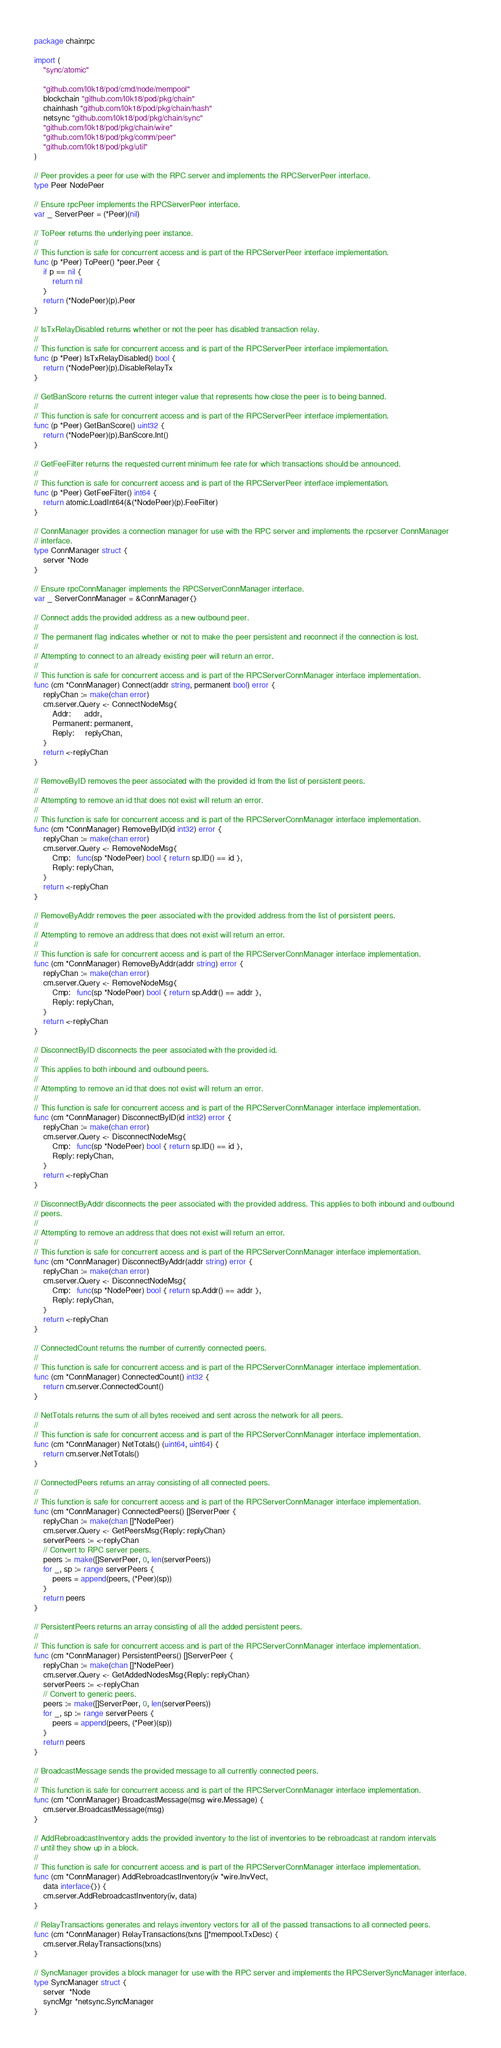<code> <loc_0><loc_0><loc_500><loc_500><_Go_>package chainrpc

import (
	"sync/atomic"

	"github.com/l0k18/pod/cmd/node/mempool"
	blockchain "github.com/l0k18/pod/pkg/chain"
	chainhash "github.com/l0k18/pod/pkg/chain/hash"
	netsync "github.com/l0k18/pod/pkg/chain/sync"
	"github.com/l0k18/pod/pkg/chain/wire"
	"github.com/l0k18/pod/pkg/comm/peer"
	"github.com/l0k18/pod/pkg/util"
)

// Peer provides a peer for use with the RPC server and implements the RPCServerPeer interface.
type Peer NodePeer

// Ensure rpcPeer implements the RPCServerPeer interface.
var _ ServerPeer = (*Peer)(nil)

// ToPeer returns the underlying peer instance.
//
// This function is safe for concurrent access and is part of the RPCServerPeer interface implementation.
func (p *Peer) ToPeer() *peer.Peer {
	if p == nil {
		return nil
	}
	return (*NodePeer)(p).Peer
}

// IsTxRelayDisabled returns whether or not the peer has disabled transaction relay.
//
// This function is safe for concurrent access and is part of the RPCServerPeer interface implementation.
func (p *Peer) IsTxRelayDisabled() bool {
	return (*NodePeer)(p).DisableRelayTx
}

// GetBanScore returns the current integer value that represents how close the peer is to being banned.
//
// This function is safe for concurrent access and is part of the RPCServerPeer interface implementation.
func (p *Peer) GetBanScore() uint32 {
	return (*NodePeer)(p).BanScore.Int()
}

// GetFeeFilter returns the requested current minimum fee rate for which transactions should be announced.
//
// This function is safe for concurrent access and is part of the RPCServerPeer interface implementation.
func (p *Peer) GetFeeFilter() int64 {
	return atomic.LoadInt64(&(*NodePeer)(p).FeeFilter)
}

// ConnManager provides a connection manager for use with the RPC server and implements the rpcserver ConnManager
// interface.
type ConnManager struct {
	server *Node
}

// Ensure rpcConnManager implements the RPCServerConnManager interface.
var _ ServerConnManager = &ConnManager{}

// Connect adds the provided address as a new outbound peer.
//
// The permanent flag indicates whether or not to make the peer persistent and reconnect if the connection is lost.
//
// Attempting to connect to an already existing peer will return an error.
//
// This function is safe for concurrent access and is part of the RPCServerConnManager interface implementation.
func (cm *ConnManager) Connect(addr string, permanent bool) error {
	replyChan := make(chan error)
	cm.server.Query <- ConnectNodeMsg{
		Addr:      addr,
		Permanent: permanent,
		Reply:     replyChan,
	}
	return <-replyChan
}

// RemoveByID removes the peer associated with the provided id from the list of persistent peers.
//
// Attempting to remove an id that does not exist will return an error.
//
// This function is safe for concurrent access and is part of the RPCServerConnManager interface implementation.
func (cm *ConnManager) RemoveByID(id int32) error {
	replyChan := make(chan error)
	cm.server.Query <- RemoveNodeMsg{
		Cmp:   func(sp *NodePeer) bool { return sp.ID() == id },
		Reply: replyChan,
	}
	return <-replyChan
}

// RemoveByAddr removes the peer associated with the provided address from the list of persistent peers.
//
// Attempting to remove an address that does not exist will return an error.
//
// This function is safe for concurrent access and is part of the RPCServerConnManager interface implementation.
func (cm *ConnManager) RemoveByAddr(addr string) error {
	replyChan := make(chan error)
	cm.server.Query <- RemoveNodeMsg{
		Cmp:   func(sp *NodePeer) bool { return sp.Addr() == addr },
		Reply: replyChan,
	}
	return <-replyChan
}

// DisconnectByID disconnects the peer associated with the provided id.
//
// This applies to both inbound and outbound peers.
//
// Attempting to remove an id that does not exist will return an error.
//
// This function is safe for concurrent access and is part of the RPCServerConnManager interface implementation.
func (cm *ConnManager) DisconnectByID(id int32) error {
	replyChan := make(chan error)
	cm.server.Query <- DisconnectNodeMsg{
		Cmp:   func(sp *NodePeer) bool { return sp.ID() == id },
		Reply: replyChan,
	}
	return <-replyChan
}

// DisconnectByAddr disconnects the peer associated with the provided address. This applies to both inbound and outbound
// peers.
//
// Attempting to remove an address that does not exist will return an error.
//
// This function is safe for concurrent access and is part of the RPCServerConnManager interface implementation.
func (cm *ConnManager) DisconnectByAddr(addr string) error {
	replyChan := make(chan error)
	cm.server.Query <- DisconnectNodeMsg{
		Cmp:   func(sp *NodePeer) bool { return sp.Addr() == addr },
		Reply: replyChan,
	}
	return <-replyChan
}

// ConnectedCount returns the number of currently connected peers.
//
// This function is safe for concurrent access and is part of the RPCServerConnManager interface implementation.
func (cm *ConnManager) ConnectedCount() int32 {
	return cm.server.ConnectedCount()
}

// NetTotals returns the sum of all bytes received and sent across the network for all peers.
//
// This function is safe for concurrent access and is part of the RPCServerConnManager interface implementation.
func (cm *ConnManager) NetTotals() (uint64, uint64) {
	return cm.server.NetTotals()
}

// ConnectedPeers returns an array consisting of all connected peers.
//
// This function is safe for concurrent access and is part of the RPCServerConnManager interface implementation.
func (cm *ConnManager) ConnectedPeers() []ServerPeer {
	replyChan := make(chan []*NodePeer)
	cm.server.Query <- GetPeersMsg{Reply: replyChan}
	serverPeers := <-replyChan
	// Convert to RPC server peers.
	peers := make([]ServerPeer, 0, len(serverPeers))
	for _, sp := range serverPeers {
		peers = append(peers, (*Peer)(sp))
	}
	return peers
}

// PersistentPeers returns an array consisting of all the added persistent peers.
//
// This function is safe for concurrent access and is part of the RPCServerConnManager interface implementation.
func (cm *ConnManager) PersistentPeers() []ServerPeer {
	replyChan := make(chan []*NodePeer)
	cm.server.Query <- GetAddedNodesMsg{Reply: replyChan}
	serverPeers := <-replyChan
	// Convert to generic peers.
	peers := make([]ServerPeer, 0, len(serverPeers))
	for _, sp := range serverPeers {
		peers = append(peers, (*Peer)(sp))
	}
	return peers
}

// BroadcastMessage sends the provided message to all currently connected peers.
//
// This function is safe for concurrent access and is part of the RPCServerConnManager interface implementation.
func (cm *ConnManager) BroadcastMessage(msg wire.Message) {
	cm.server.BroadcastMessage(msg)
}

// AddRebroadcastInventory adds the provided inventory to the list of inventories to be rebroadcast at random intervals
// until they show up in a block.
//
// This function is safe for concurrent access and is part of the RPCServerConnManager interface implementation.
func (cm *ConnManager) AddRebroadcastInventory(iv *wire.InvVect,
	data interface{}) {
	cm.server.AddRebroadcastInventory(iv, data)
}

// RelayTransactions generates and relays inventory vectors for all of the passed transactions to all connected peers.
func (cm *ConnManager) RelayTransactions(txns []*mempool.TxDesc) {
	cm.server.RelayTransactions(txns)
}

// SyncManager provides a block manager for use with the RPC server and implements the RPCServerSyncManager interface.
type SyncManager struct {
	server  *Node
	syncMgr *netsync.SyncManager
}
</code> 